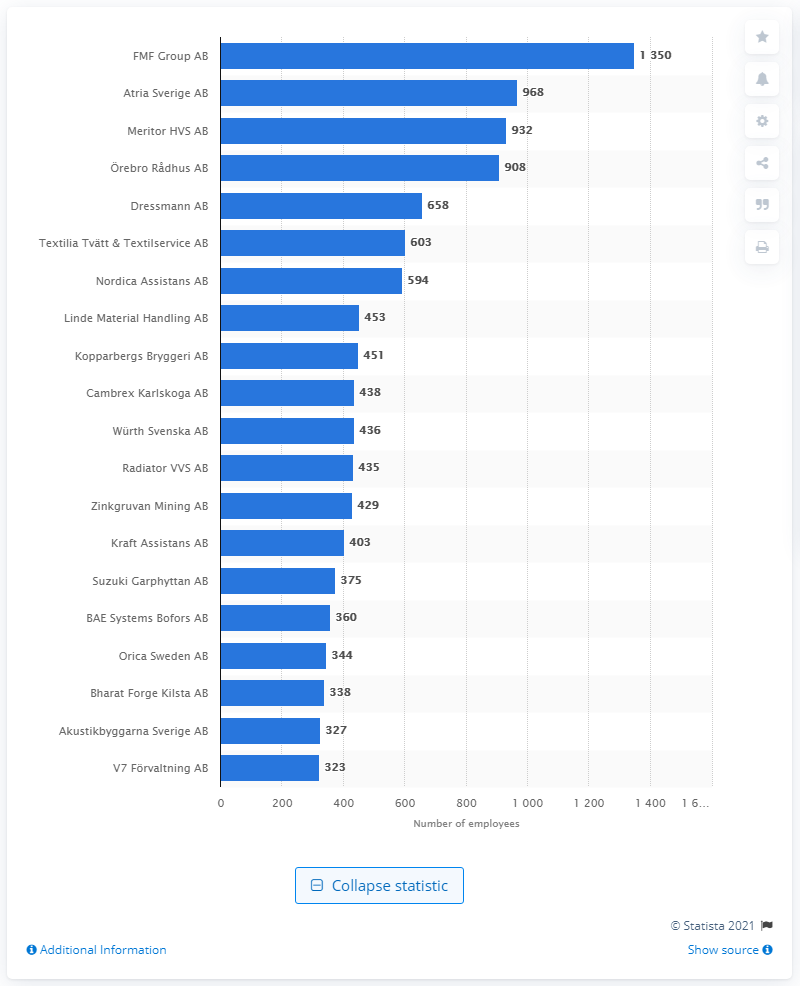Outline some significant characteristics in this image. The second largest company in Rebbro County in 2021 was Meritor HVS AB. The FMF Group AB was the largest company in the county of Rebbro in 2021. In 2021, FMF Group AB was the largest company in Rebbro County. 